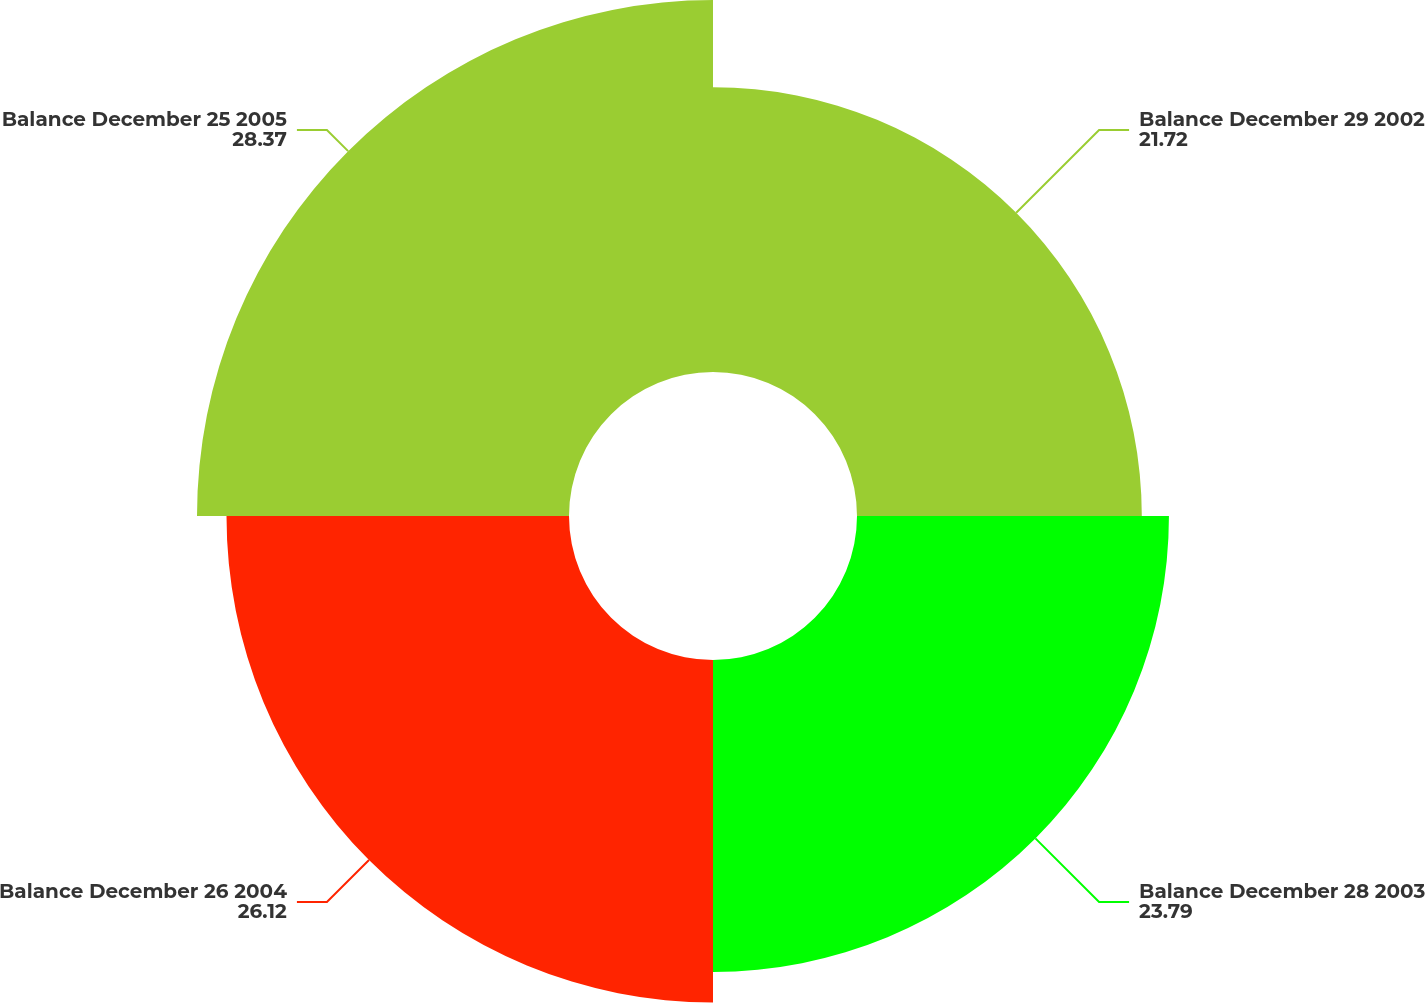Convert chart to OTSL. <chart><loc_0><loc_0><loc_500><loc_500><pie_chart><fcel>Balance December 29 2002<fcel>Balance December 28 2003<fcel>Balance December 26 2004<fcel>Balance December 25 2005<nl><fcel>21.72%<fcel>23.79%<fcel>26.12%<fcel>28.37%<nl></chart> 